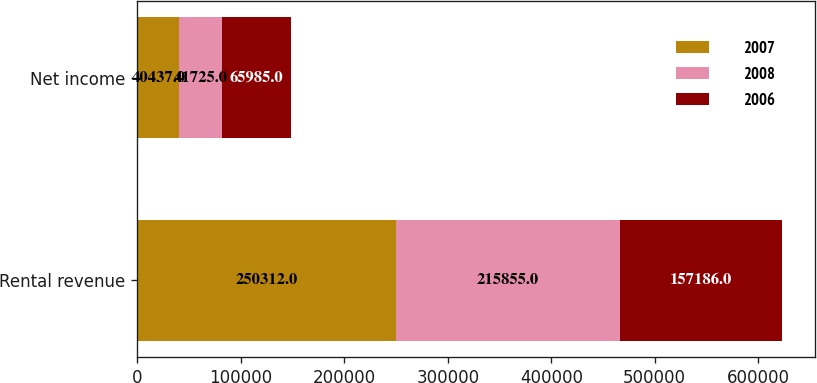Convert chart. <chart><loc_0><loc_0><loc_500><loc_500><stacked_bar_chart><ecel><fcel>Rental revenue<fcel>Net income<nl><fcel>2007<fcel>250312<fcel>40437<nl><fcel>2008<fcel>215855<fcel>41725<nl><fcel>2006<fcel>157186<fcel>65985<nl></chart> 